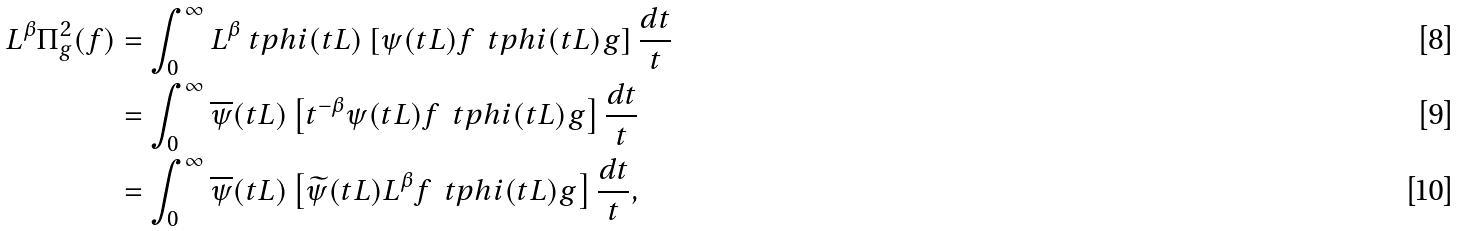Convert formula to latex. <formula><loc_0><loc_0><loc_500><loc_500>L ^ { \beta } \Pi ^ { 2 } _ { g } ( f ) & = \int _ { 0 } ^ { \infty } L ^ { \beta } \ t p h i ( t L ) \left [ \psi ( t L ) f \, \ t p h i ( t L ) g \right ] \frac { d t } { t } \\ & = \int _ { 0 } ^ { \infty } \overline { \psi } ( t L ) \left [ t ^ { - \beta } \psi ( t L ) f \, \ t p h i ( t L ) g \right ] \frac { d t } { t } \\ & = \int _ { 0 } ^ { \infty } \overline { \psi } ( t L ) \left [ \widetilde { \psi } ( t L ) L ^ { \beta } f \, \ t p h i ( t L ) g \right ] \frac { d t } { t } ,</formula> 